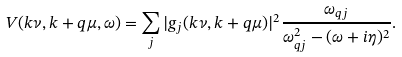Convert formula to latex. <formula><loc_0><loc_0><loc_500><loc_500>V ( { k } \nu , { k } + { q } \mu , \omega ) = \sum _ { j } | g _ { j } ( { k } \nu , { k } + { q } \mu ) | ^ { 2 } \frac { \omega _ { { q } j } } { \omega _ { { q } j } ^ { 2 } - ( \omega + i \eta ) ^ { 2 } } .</formula> 